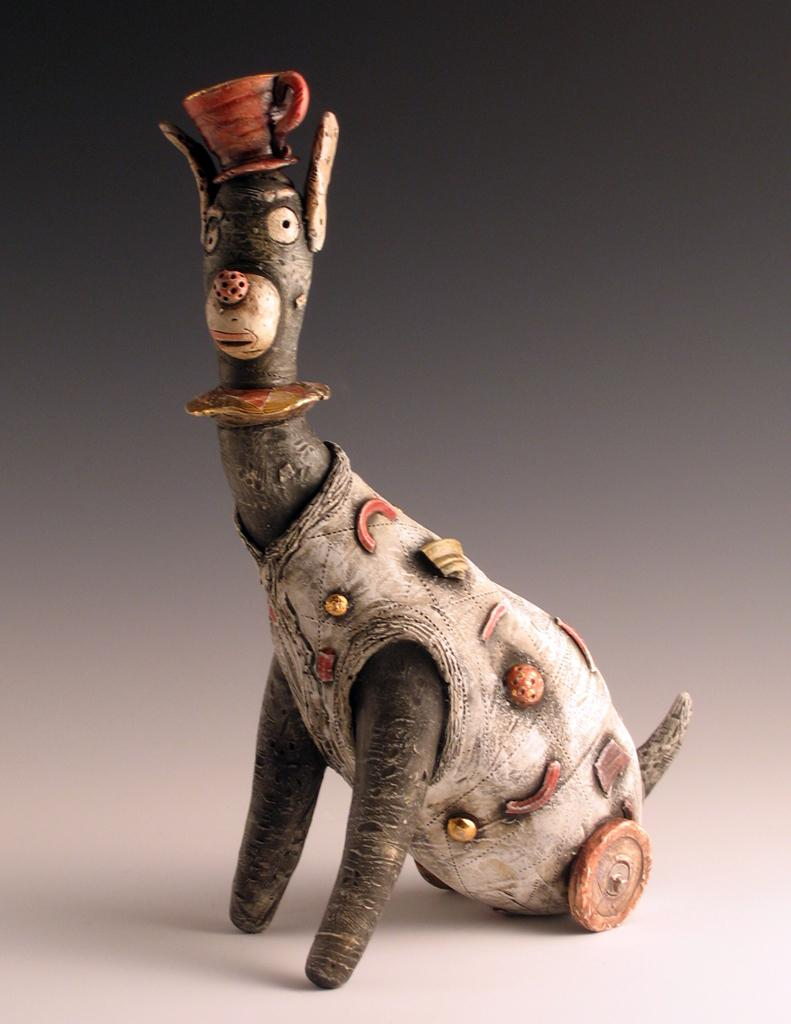What object is the main focus of the image? There is a toy in the image. What is unique about the toy's appearance? The toy has a cup on its head. What color is the background of the image? The background of the image is gray. What type of battle is taking place in the image? There is no battle present in the image; it features a toy with a cup on its head against a gray background. How many crows can be seen in the image? There are no crows present in the image. 